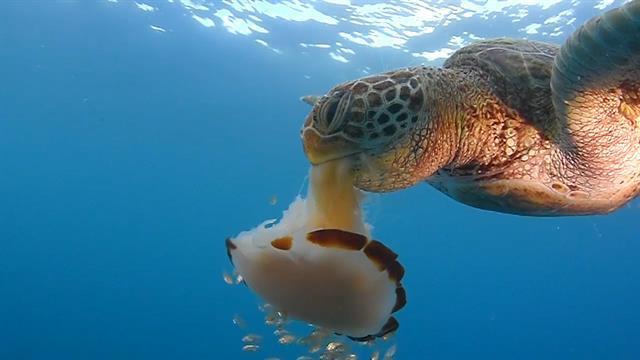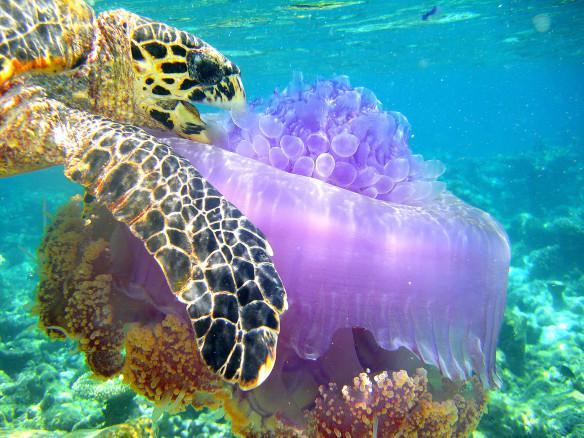The first image is the image on the left, the second image is the image on the right. Analyze the images presented: Is the assertion "A sea turtle with distinctly textured skin has its open mouth next to a purplish saucer-shaped jellyfish." valid? Answer yes or no. Yes. The first image is the image on the left, the second image is the image on the right. Evaluate the accuracy of this statement regarding the images: "There is a sea turtle that is taking a bite at what appears to be a purple jellyfish.". Is it true? Answer yes or no. Yes. 